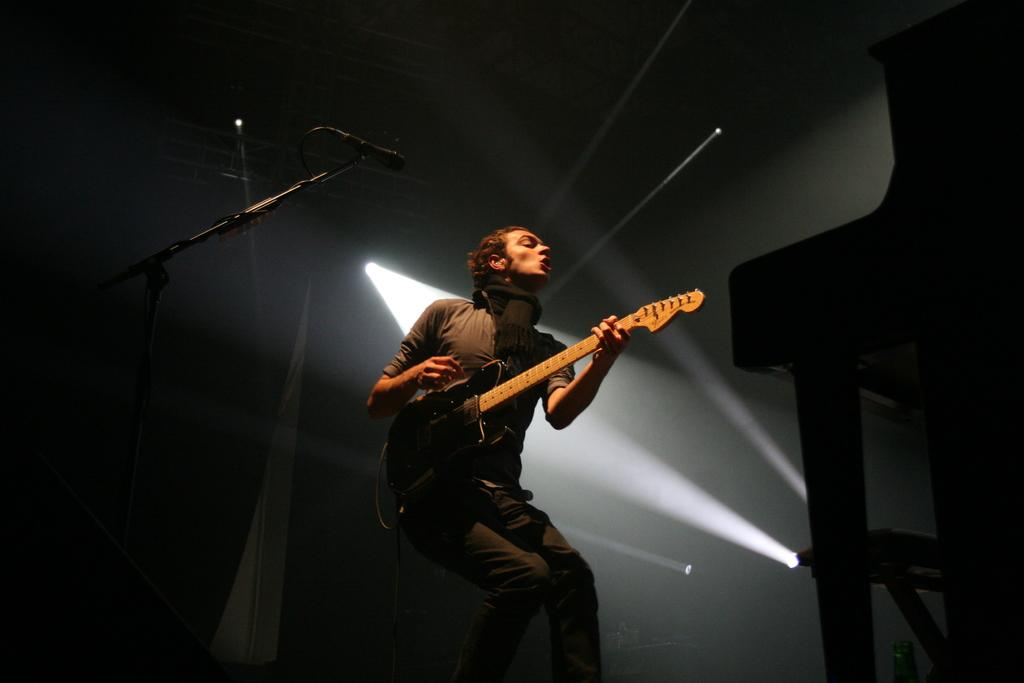What is the main subject of the image? There is a man in the image. What is the man doing in the image? The man is standing in the image. What object is the man holding in the image? The man is holding a guitar in the image. What can be seen in the background of the image? There is a light visible in the background of the image. How much water is present in the image? There is no water visible in the image. What part of the guitar is the man playing in the image? The image does not show the man playing the guitar, only holding it. 